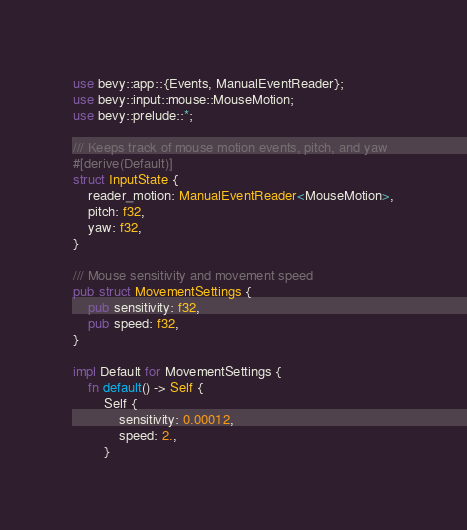<code> <loc_0><loc_0><loc_500><loc_500><_Rust_>use bevy::app::{Events, ManualEventReader};
use bevy::input::mouse::MouseMotion;
use bevy::prelude::*;

/// Keeps track of mouse motion events, pitch, and yaw
#[derive(Default)]
struct InputState {
    reader_motion: ManualEventReader<MouseMotion>,
    pitch: f32,
    yaw: f32,
}

/// Mouse sensitivity and movement speed
pub struct MovementSettings {
    pub sensitivity: f32,
    pub speed: f32,
}

impl Default for MovementSettings {
    fn default() -> Self {
        Self {
            sensitivity: 0.00012,
            speed: 2.,
        }</code> 